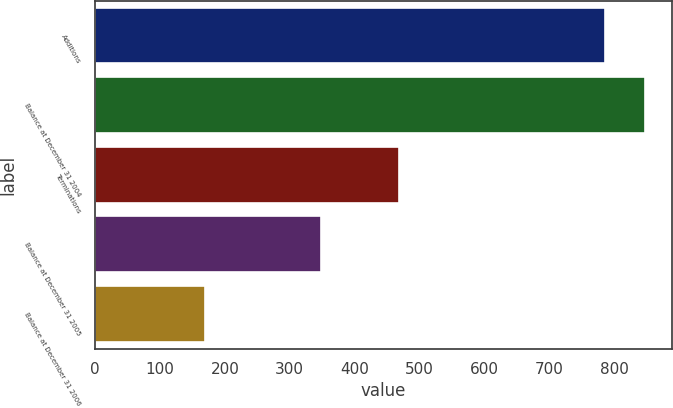Convert chart. <chart><loc_0><loc_0><loc_500><loc_500><bar_chart><fcel>Additions<fcel>Balance at December 31 2004<fcel>Terminations<fcel>Balance at December 31 2005<fcel>Balance at December 31 2006<nl><fcel>785<fcel>846.5<fcel>468<fcel>348<fcel>170<nl></chart> 